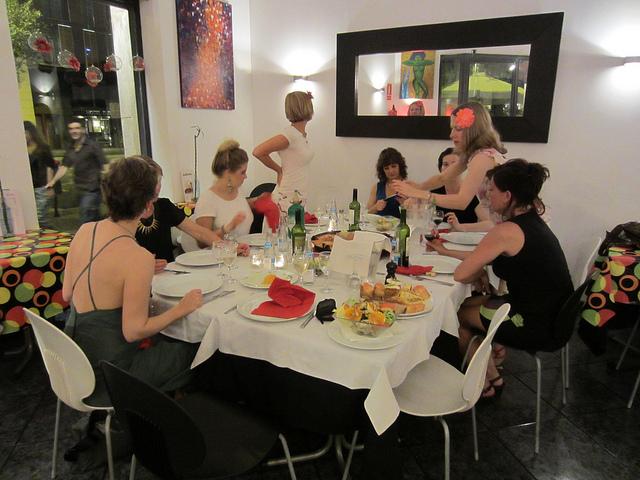How many people are there?
Write a very short answer. 8. What are they eating?
Give a very brief answer. Food. Is this a restaurant?
Write a very short answer. Yes. Have these people been served food yet?
Short answer required. Yes. What is on the back wall behind them?
Write a very short answer. Mirror. What is the hairstyle of the fourth woman on the left?
Keep it brief. Short. How many hanging plants are there?
Write a very short answer. 1. Is this picture in color or black and white?
Give a very brief answer. Color. Is this a buffet?
Concise answer only. No. Where is the roll?
Short answer required. Plate. What is the table made out of?
Be succinct. Wood. What game is the family playing?
Give a very brief answer. Charades. How many real people are in the picture?
Concise answer only. 8. How many women are wearing white dresses?
Short answer required. 2. Is there food on the table?
Be succinct. Yes. Who is standing?
Keep it brief. Women. How many people are sitting at the table?
Be succinct. 8. Where is the woman's red napkin?
Short answer required. Plate. 